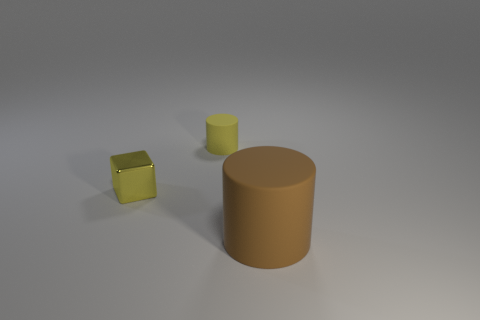Is there anything else that has the same size as the brown rubber thing?
Give a very brief answer. No. Is there anything else that is the same shape as the small yellow shiny object?
Give a very brief answer. No. There is a small yellow metal block; how many cylinders are in front of it?
Make the answer very short. 1. The other rubber object that is the same shape as the brown object is what size?
Ensure brevity in your answer.  Small. How many yellow things are big rubber cylinders or tiny matte spheres?
Your response must be concise. 0. There is a cylinder that is behind the large rubber object; how many tiny yellow things are left of it?
Your answer should be compact. 1. How many other objects are the same shape as the large brown rubber thing?
Your answer should be very brief. 1. What is the material of the block that is the same color as the tiny rubber thing?
Offer a very short reply. Metal. What number of cylinders are the same color as the small metallic cube?
Offer a terse response. 1. The cylinder that is made of the same material as the big brown thing is what color?
Provide a short and direct response. Yellow. 